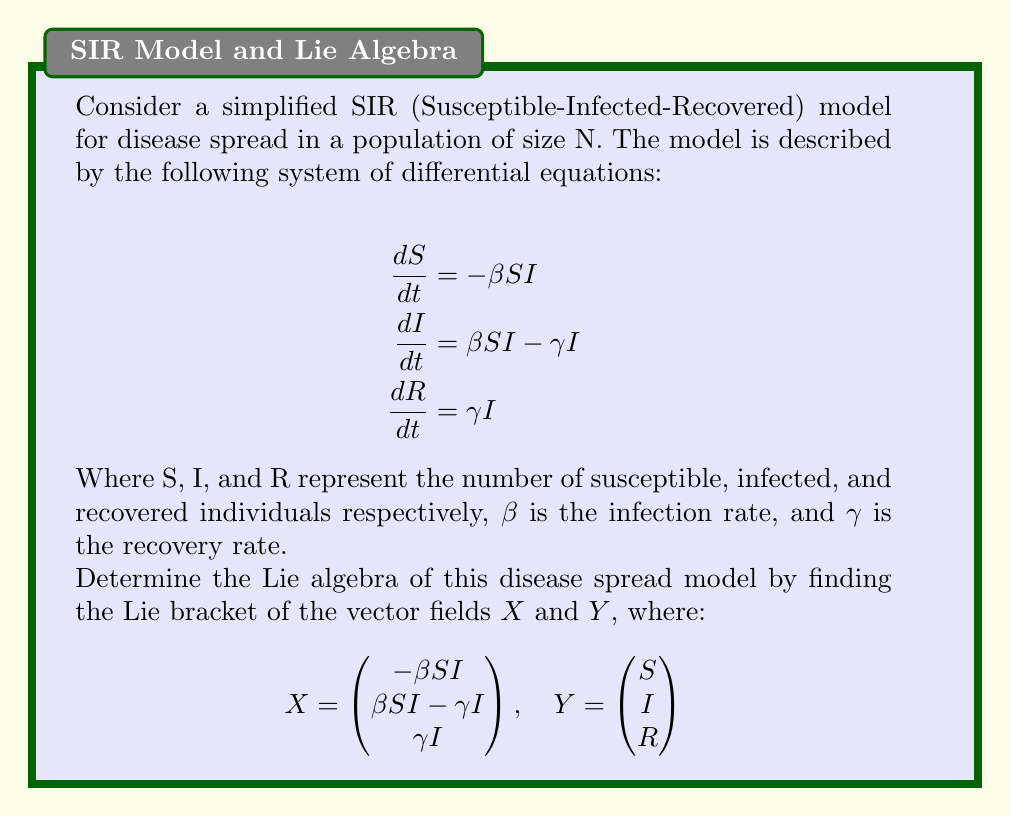Solve this math problem. To determine the Lie algebra, we need to calculate the Lie bracket [X, Y]. The Lie bracket is defined as:

$$[X, Y] = \frac{\partial Y}{\partial \mathbf{x}} X - \frac{\partial X}{\partial \mathbf{x}} Y$$

Where $\frac{\partial}{\partial \mathbf{x}}$ represents the Jacobian matrix.

Step 1: Calculate $\frac{\partial Y}{\partial \mathbf{x}}$
$$\frac{\partial Y}{\partial \mathbf{x}} = \begin{pmatrix}
1 & 0 & 0 \\
0 & 1 & 0 \\
0 & 0 & 1
\end{pmatrix}$$

Step 2: Calculate $\frac{\partial X}{\partial \mathbf{x}}$
$$\frac{\partial X}{\partial \mathbf{x}} = \begin{pmatrix}
-\beta I & -\beta S & 0 \\
\beta I & \beta S - \gamma & 0 \\
0 & \gamma & 0
\end{pmatrix}$$

Step 3: Calculate $\frac{\partial Y}{\partial \mathbf{x}} X$
$$\frac{\partial Y}{\partial \mathbf{x}} X = \begin{pmatrix}
-\beta SI \\
\beta SI - \gamma I \\
\gamma I
\end{pmatrix}$$

Step 4: Calculate $\frac{\partial X}{\partial \mathbf{x}} Y$
$$\frac{\partial X}{\partial \mathbf{x}} Y = \begin{pmatrix}
-\beta SI - \beta SI \\
\beta SI + \beta SI - \gamma I \\
\gamma I
\end{pmatrix} = \begin{pmatrix}
-2\beta SI \\
2\beta SI - \gamma I \\
\gamma I
\end{pmatrix}$$

Step 5: Calculate the Lie bracket [X, Y]
$$[X, Y] = \frac{\partial Y}{\partial \mathbf{x}} X - \frac{\partial X}{\partial \mathbf{x}} Y = \begin{pmatrix}
-\beta SI \\
\beta SI - \gamma I \\
\gamma I
\end{pmatrix} - \begin{pmatrix}
-2\beta SI \\
2\beta SI - \gamma I \\
\gamma I
\end{pmatrix} = \begin{pmatrix}
\beta SI \\
-\beta SI \\
0
\end{pmatrix}$$

Therefore, the Lie bracket [X, Y] represents the vector field of the disease spread model.
Answer: $[X, Y] = (\beta SI, -\beta SI, 0)^T$ 